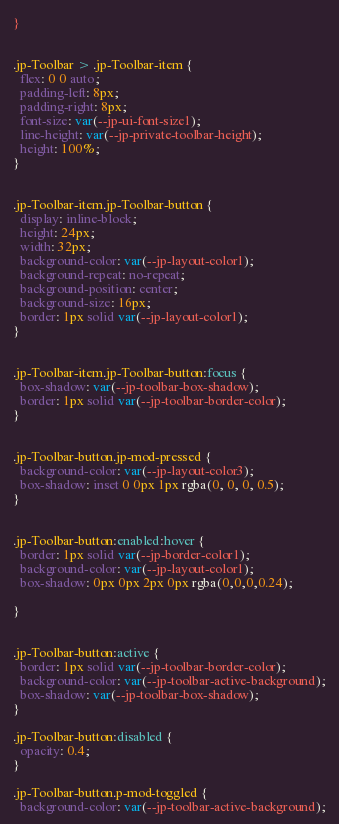Convert code to text. <code><loc_0><loc_0><loc_500><loc_500><_CSS_>}


.jp-Toolbar > .jp-Toolbar-item {
  flex: 0 0 auto;
  padding-left: 8px;
  padding-right: 8px;
  font-size: var(--jp-ui-font-size1);
  line-height: var(--jp-private-toolbar-height);
  height: 100%;
}


.jp-Toolbar-item.jp-Toolbar-button {
  display: inline-block;
  height: 24px;
  width: 32px;
  background-color: var(--jp-layout-color1);
  background-repeat: no-repeat;
  background-position: center;
  background-size: 16px;
  border: 1px solid var(--jp-layout-color1);
}


.jp-Toolbar-item.jp-Toolbar-button:focus {
  box-shadow: var(--jp-toolbar-box-shadow);
  border: 1px solid var(--jp-toolbar-border-color);
}


.jp-Toolbar-button.jp-mod-pressed {
  background-color: var(--jp-layout-color3);
  box-shadow: inset 0 0px 1px rgba(0, 0, 0, 0.5);
}


.jp-Toolbar-button:enabled:hover {
  border: 1px solid var(--jp-border-color1);
  background-color: var(--jp-layout-color1);
  box-shadow: 0px 0px 2px 0px rgba(0,0,0,0.24);

}


.jp-Toolbar-button:active {
  border: 1px solid var(--jp-toolbar-border-color);
  background-color: var(--jp-toolbar-active-background);
  box-shadow: var(--jp-toolbar-box-shadow);
}

.jp-Toolbar-button:disabled {
  opacity: 0.4;
}

.jp-Toolbar-button.p-mod-toggled {
  background-color: var(--jp-toolbar-active-background);</code> 